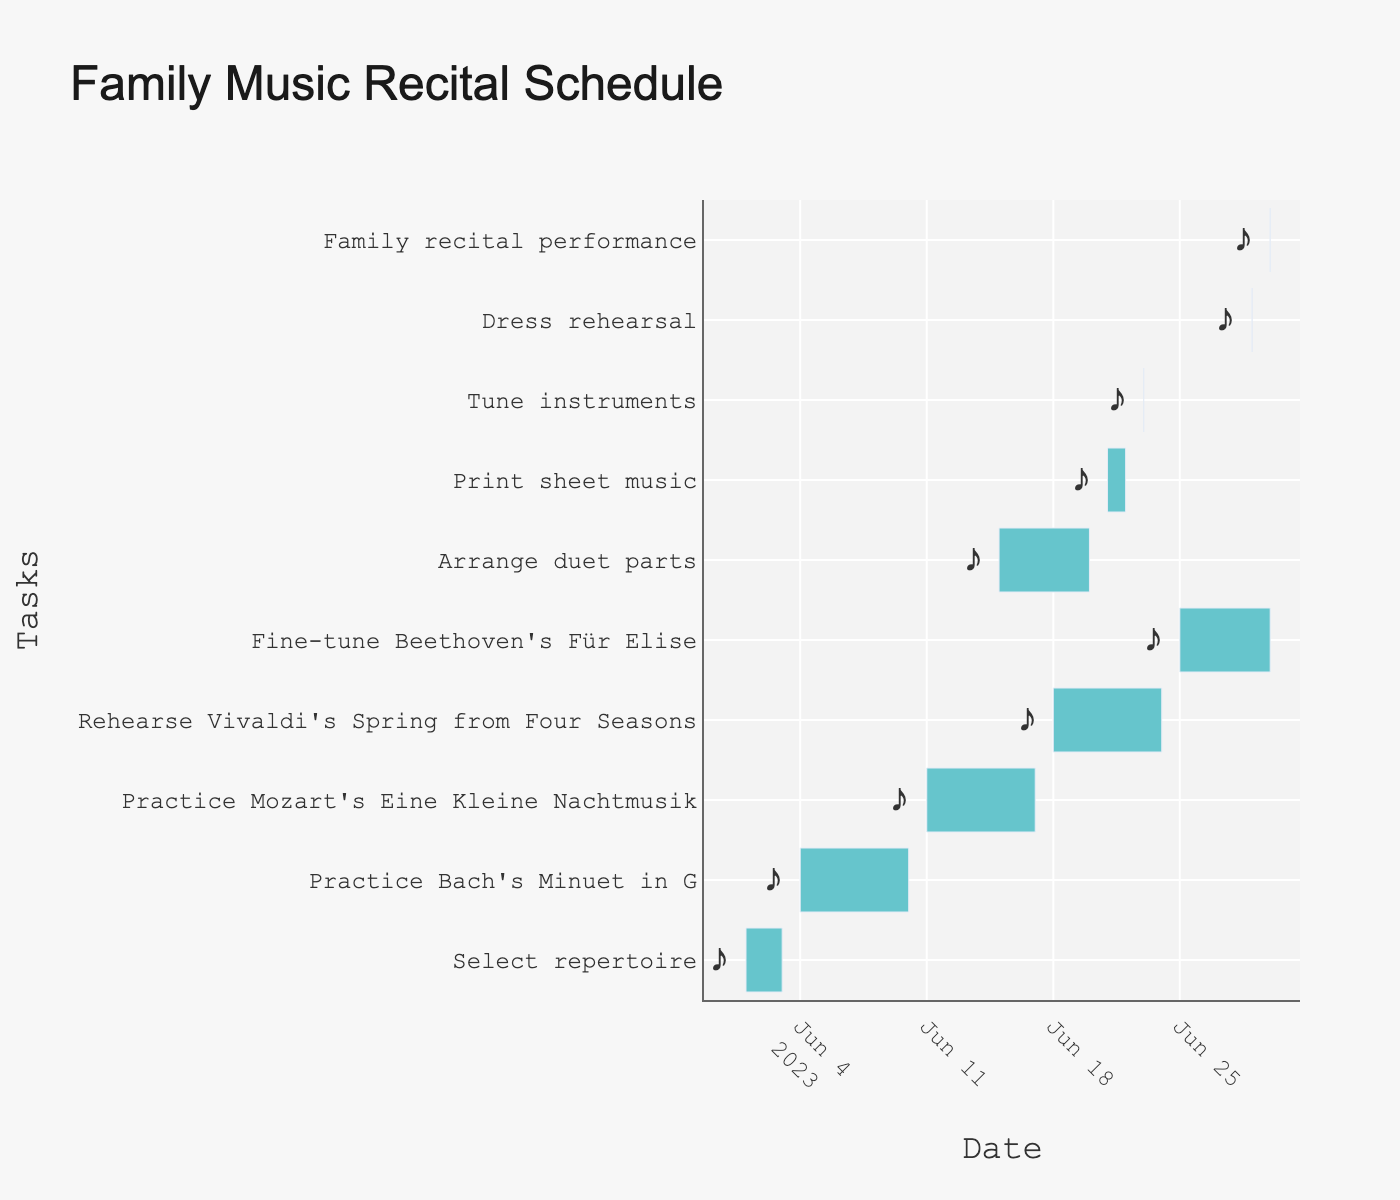What is the title of the chart? The title is typically found at the top of the chart and provides an overview of what the chart is about.
Answer: Family Music Recital Schedule How long is the period for practicing 'Bach's Minuet in G'? Look for the task "Practice Bach's Minuet in G" and note the start and end dates. Then, calculate the duration.
Answer: 7 days Which task has the shortest duration? Compare the length of each task bar. Identify the task with the shortest bar, indicating the shortest duration.
Answer: Tune instruments Between which dates is the 'Arrange duet parts' task scheduled? Find the 'Arrange duet parts' task on the Y-axis and check its start and end dates on the X-axis.
Answer: 2023-06-15 to 2023-06-20 Which tasks are scheduled on June 30? Identify all tasks with the end date of June 30 on the X-axis.
Answer: Fine-tune Beethoven's Für Elise, Family recital performance What is the duration between the start of 'Select repertoire' and the end of 'Family recital performance'? Find the start date of 'Select repertoire' and the end date of 'Family recital performance'. Then, count the days between these two dates.
Answer: 30 days How many tasks are overlapping with 'Arrange duet parts'? Look for tasks on the Y-axis that overlap with 'Arrange duet parts' on the timeline.
Answer: 1 task Which task comes immediately after 'Rehearse Vivaldi's Spring from Four Seasons'? Find the end date of 'Rehearse Vivaldi's Spring from Four Seasons' and look for the task that starts immediately after.
Answer: Fine-tune Beethoven's Für Elise List all tasks that need to be completed before the 'Dress rehearsal'. Locate 'Dress rehearsal' on the timeline and check all tasks that end before its start date.
Answer: Print sheet music, Tune instruments, Arrange duet parts, Rehearse Vivaldi's Spring from Four Seasons, Practice Mozart's Eine Kleine Nachtmusik, Practice Bach's Minuet in G, Select repertoire What are the overlapping dates between 'Print sheet music' and 'Tune instruments'? Compare the start and end dates of 'Print sheet music' and 'Tune instruments' and find the common dates they both cover.
Answer: June 23 